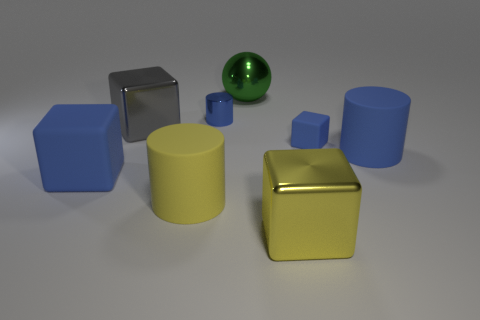Is there a yellow matte object that has the same size as the blue metal object?
Offer a very short reply. No. What is the material of the blue object that is the same size as the blue metal cylinder?
Your answer should be compact. Rubber. There is a green metal sphere; does it have the same size as the blue cylinder that is to the left of the small matte block?
Make the answer very short. No. How many matte things are either small blue cylinders or purple cylinders?
Keep it short and to the point. 0. How many blue rubber things have the same shape as the big gray metallic object?
Ensure brevity in your answer.  2. There is another tiny object that is the same color as the tiny rubber object; what is it made of?
Provide a succinct answer. Metal. Is the size of the blue matte block left of the green ball the same as the blue rubber block that is on the right side of the large yellow rubber cylinder?
Your response must be concise. No. There is a small blue object that is behind the gray metallic thing; what is its shape?
Your answer should be very brief. Cylinder. What is the material of the large blue thing that is the same shape as the large gray object?
Keep it short and to the point. Rubber. Is the size of the green thing that is behind the blue metal object the same as the big blue cube?
Your answer should be compact. Yes. 